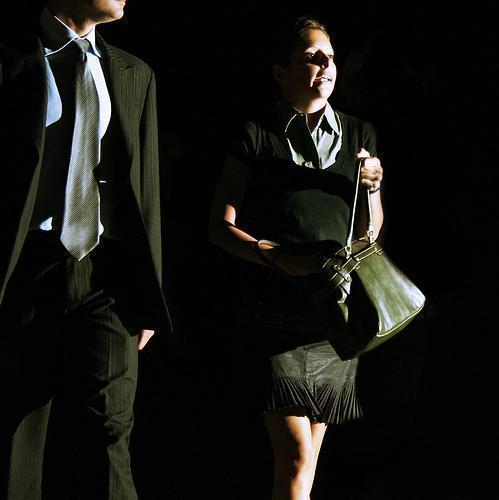What is the person on the left wearing?
Choose the right answer from the provided options to respond to the question.
Options: Tie, cat ears, suspenders, crown. Tie. 